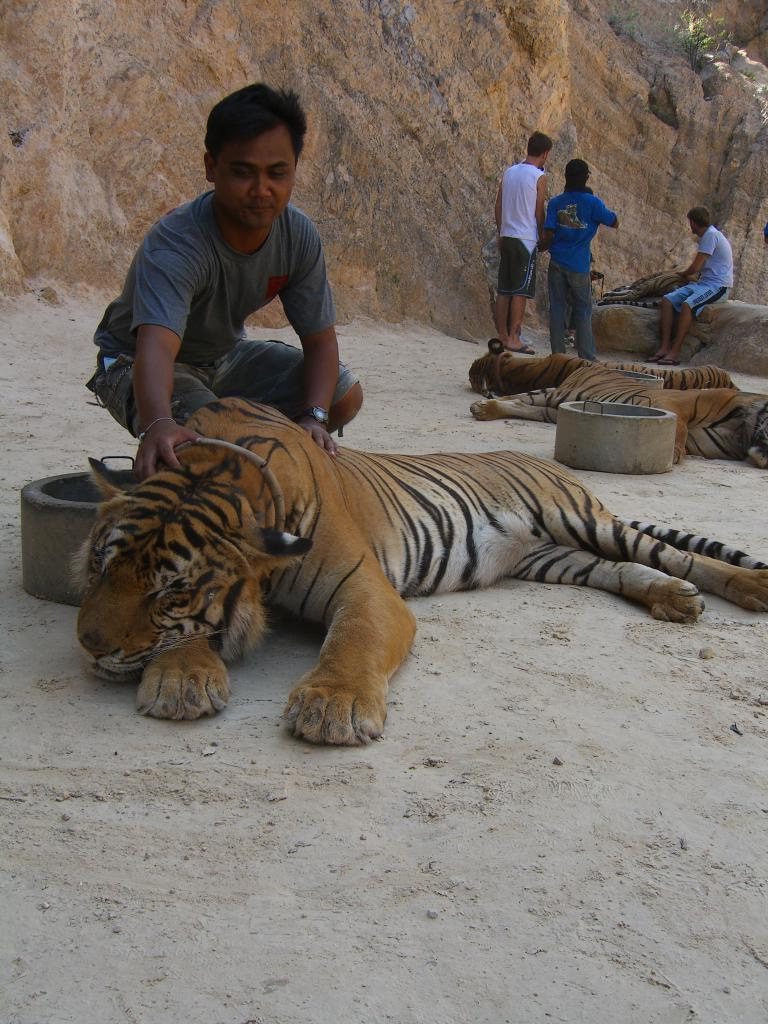What animals are lying on the ground in the image? There are tigers lying on the ground in the image. Are there any humans present in the image? Yes, there are people in the image. What can be seen in the background of the image? There are rocks visible in the background of the image. What type of teeth can be seen in the image? There is no reference to teeth in the image, as it features tigers lying on the ground and people, but no teeth are visible. 